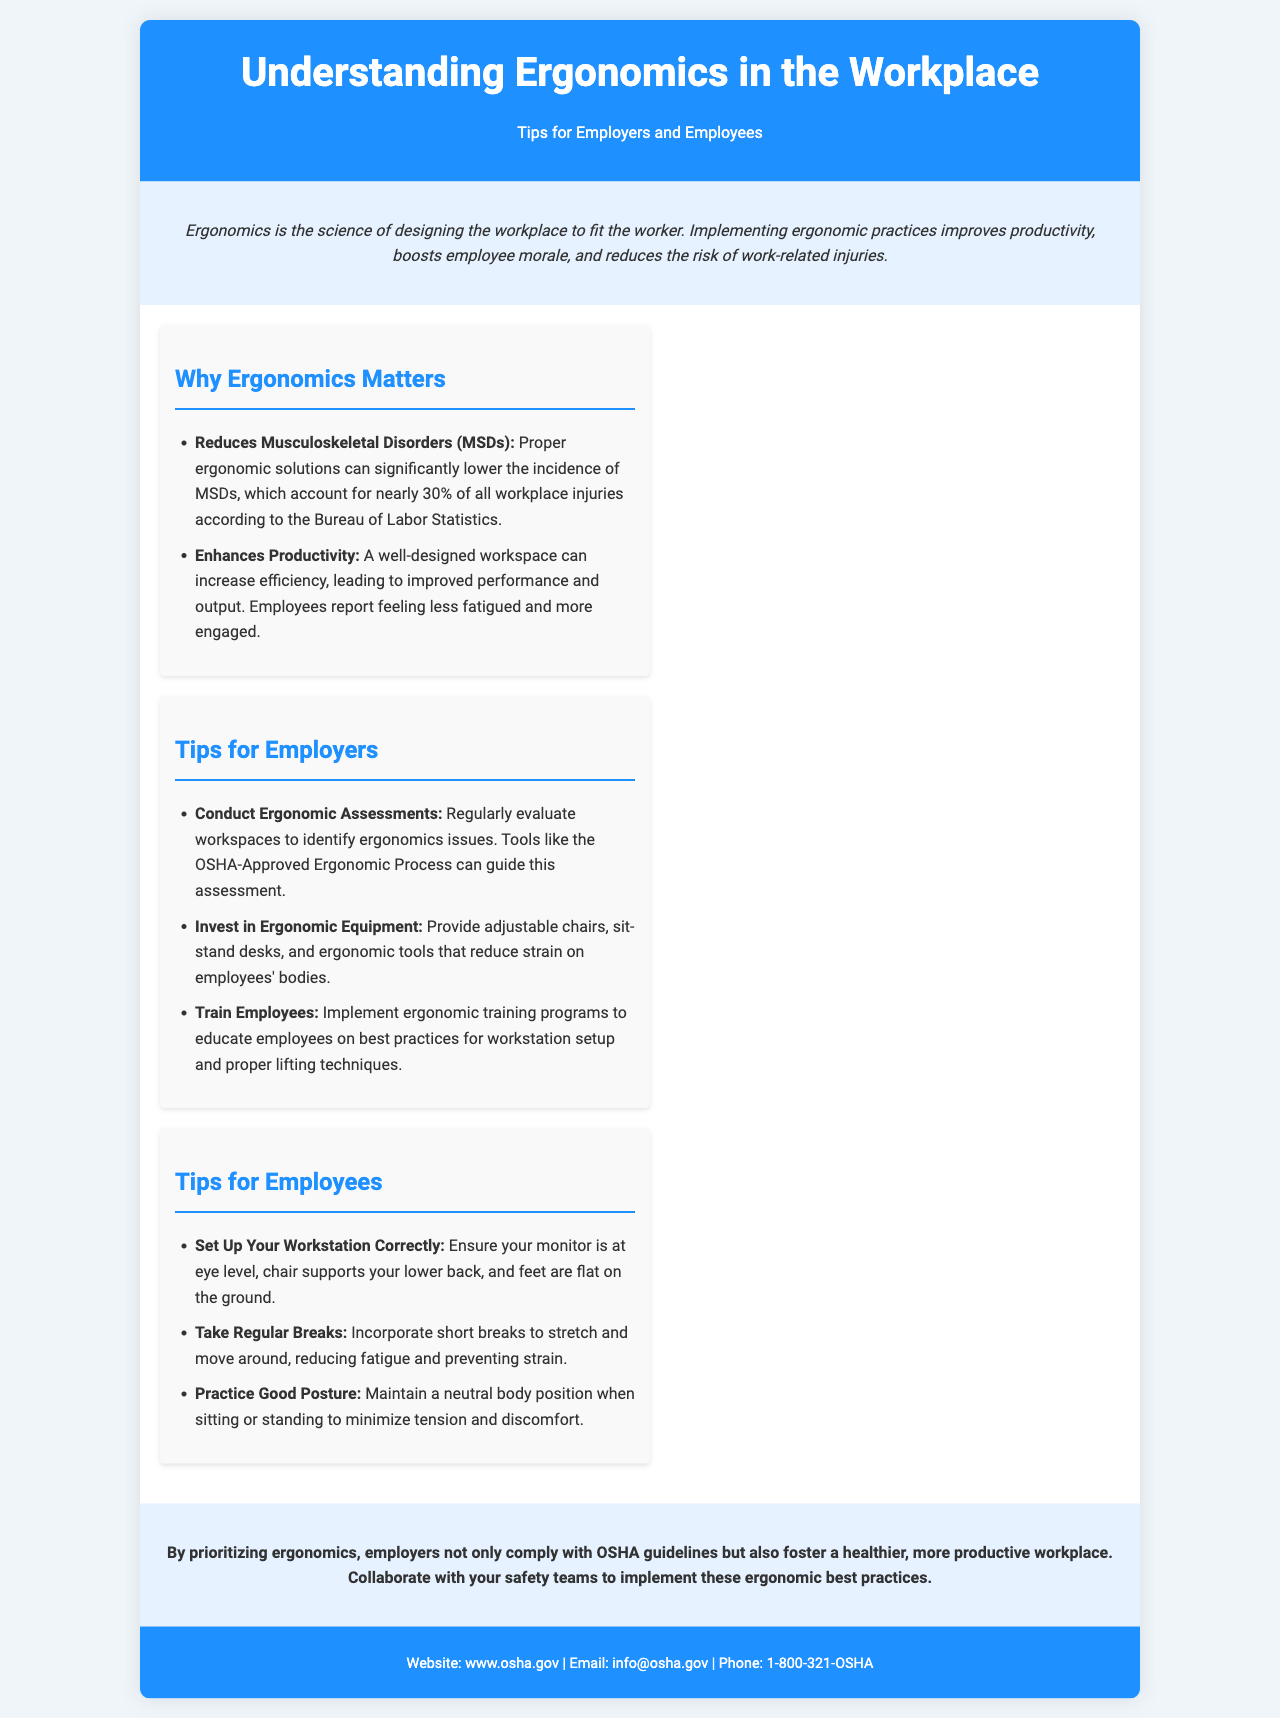What is the primary focus of ergonomics? Ergonomics is primarily focused on designing the workplace to fit the worker.
Answer: Designing the workplace to fit the worker How many percentage of workplace injuries are accounted for by MSDs? The document states that MSDs account for nearly 30% of all workplace injuries.
Answer: 30% What should employers conduct to improve ergonomic conditions? Employers should regularly conduct ergonomic assessments to identify ergonomics issues.
Answer: Ergonomic assessments What is one of the recommended investments for employers? The brochure advises employers to invest in ergonomic equipment, such as adjustable chairs.
Answer: Ergonomic equipment What are employees encouraged to maintain to reduce discomfort? Employees are encouraged to practice good posture to minimize tension and discomfort.
Answer: Good posture How does proper ergonomics affect employee productivity? Proper ergonomics enhances productivity by increasing efficiency and engagement among employees.
Answer: Enhances productivity What is a key component of the conclusion in the brochure? The conclusion emphasizes the importance of prioritizing ergonomics for a healthier workplace.
Answer: Prioritizing ergonomics Name one ergonomic practice suggested for employees. Employees are advised to take regular breaks to reduce fatigue and prevent strain.
Answer: Take regular breaks 